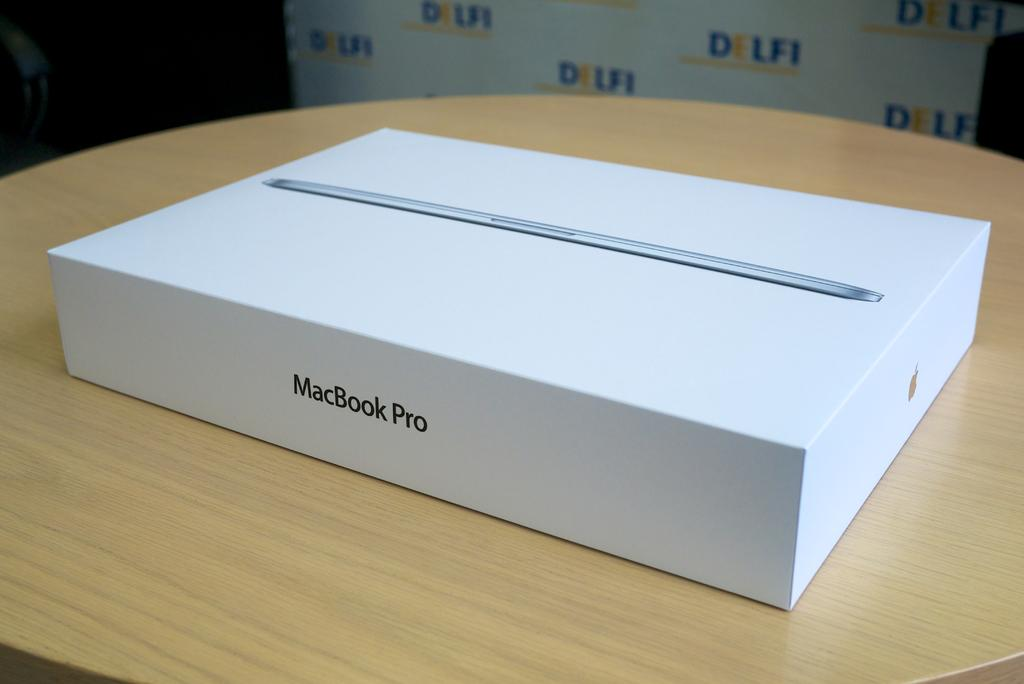Provide a one-sentence caption for the provided image. An unopened MacBook Pro sits on the table in front of a DELFI advertisement. 